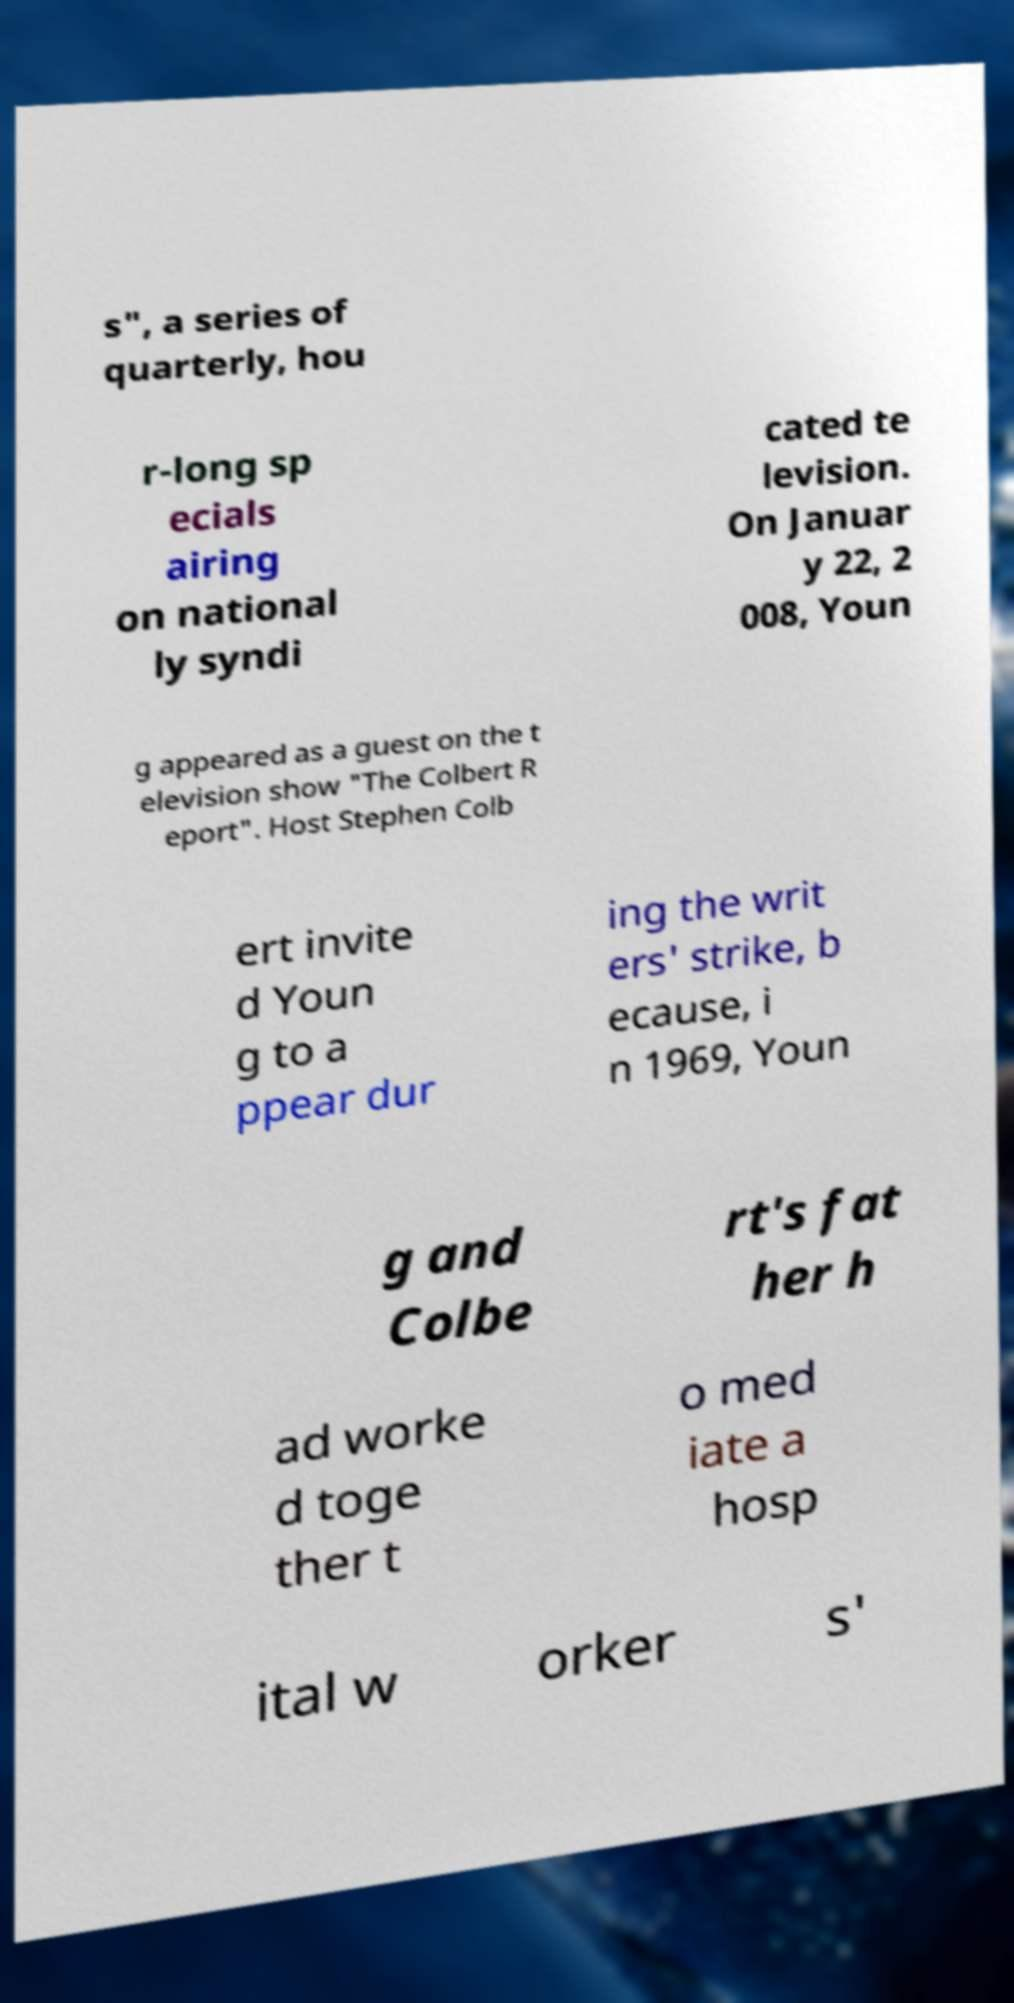Could you extract and type out the text from this image? s", a series of quarterly, hou r-long sp ecials airing on national ly syndi cated te levision. On Januar y 22, 2 008, Youn g appeared as a guest on the t elevision show "The Colbert R eport". Host Stephen Colb ert invite d Youn g to a ppear dur ing the writ ers' strike, b ecause, i n 1969, Youn g and Colbe rt's fat her h ad worke d toge ther t o med iate a hosp ital w orker s' 